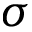Convert formula to latex. <formula><loc_0><loc_0><loc_500><loc_500>\sigma</formula> 